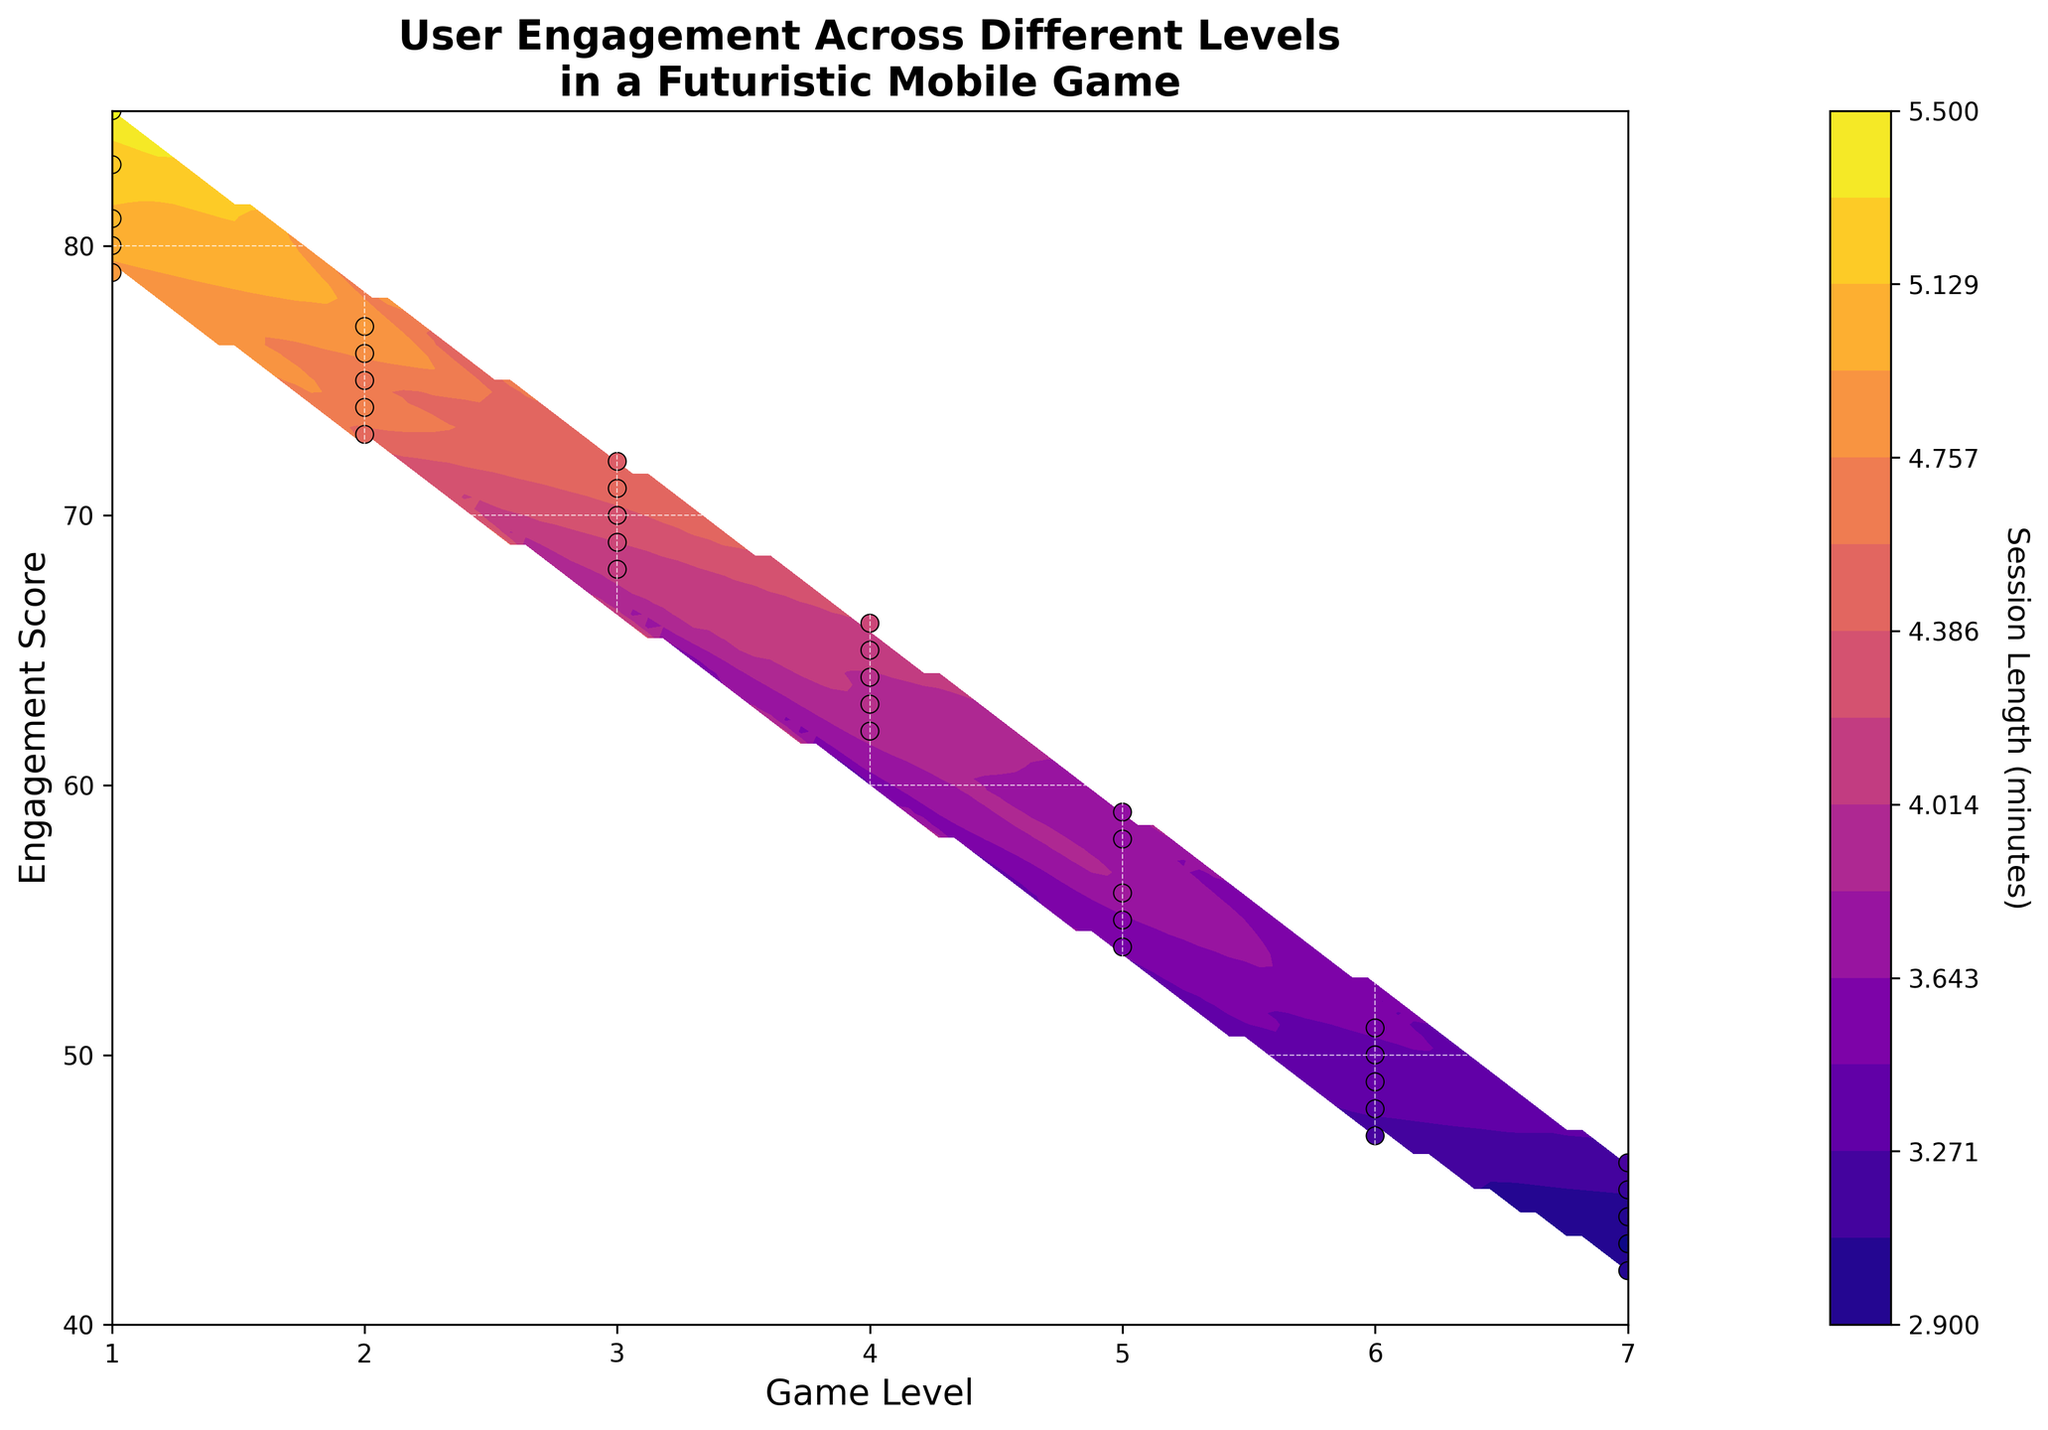What is the title of the plot? The title of the plot is located at the top center of the figure, and it reads "User Engagement Across Different Levels in a Futuristic Mobile Game".
Answer: User Engagement Across Different Levels in a Futuristic Mobile Game What's the label for the x-axis in the plot? The x-axis label is typically placed along the horizontal axis of the plot, and it reads "Game Level".
Answer: Game Level How many distinct game levels are shown on the x-axis? The x-axis tick marks help identify distinct levels, ranging from 1 to 7, indicating there are 7 distinct game levels.
Answer: 7 At which game level do users have the highest session lengths? By looking at the contour and the color intensity, the highest session lengths (darker colors) are noted around Level 1.
Answer: Level 1 What is the engagement score range across the entire plot? The y-axis tick marks show the engagement scores starting from 40 up to 90, giving us a range of 50.
Answer: 40 to 90 How does session length change from Level 1 to Level 7? Observing the gradient change in the contour plot from Level 1 to Level 7, the session length decreases as we move from Level 1 towards Level 7.
Answer: Decreases Which game level has the smallest variability in session lengths based on the contour plot? The smallest variability in session lengths is observed where the contour lines are closest together. This appears around Level 7 based on the plot.
Answer: Level 7 Are there any levels where the session length exceeds 5 minutes based on the contour plot? By inspecting the contour levels and the color intensity, sessions at Level 1 are the only ones that exceed 5 minutes.
Answer: Yes, at Level 1 What is the relationship between engagement score and session length for Level 4? Examining the scatter plot dots for Level 4, as engagement score increases, session length slightly increases but stays near 4 minutes.
Answer: Increases slightly Between which levels does the session length decrease the most rapidly? Analyzing the distance between the contours across levels, the most rapid decrease in session length appears between Level 1 and Level 2.
Answer: Between Level 1 and Level 2 